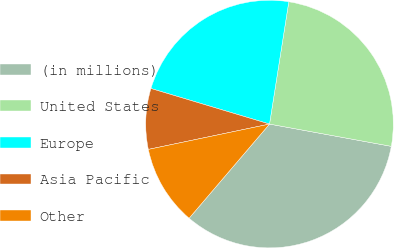Convert chart. <chart><loc_0><loc_0><loc_500><loc_500><pie_chart><fcel>(in millions)<fcel>United States<fcel>Europe<fcel>Asia Pacific<fcel>Other<nl><fcel>33.37%<fcel>25.39%<fcel>22.85%<fcel>7.92%<fcel>10.47%<nl></chart> 